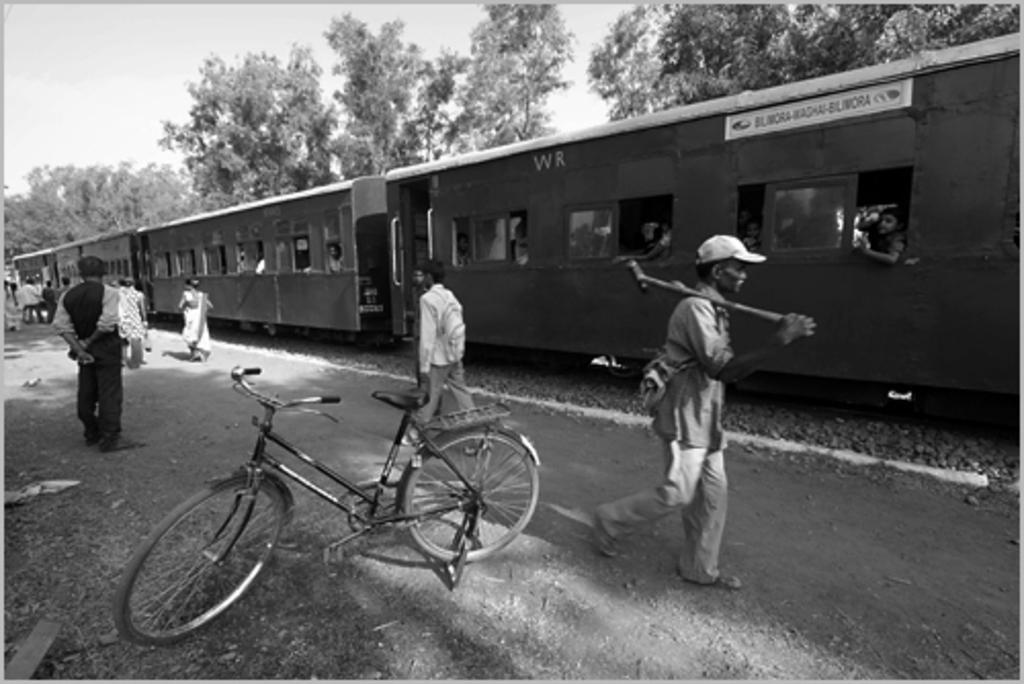Describe this image in one or two sentences. In this image we can a train and a person sitting in it. There are many trees in the image. We can see a group of people on the left most of the image. A person is moving towards the right side of the image and carrying some object. 